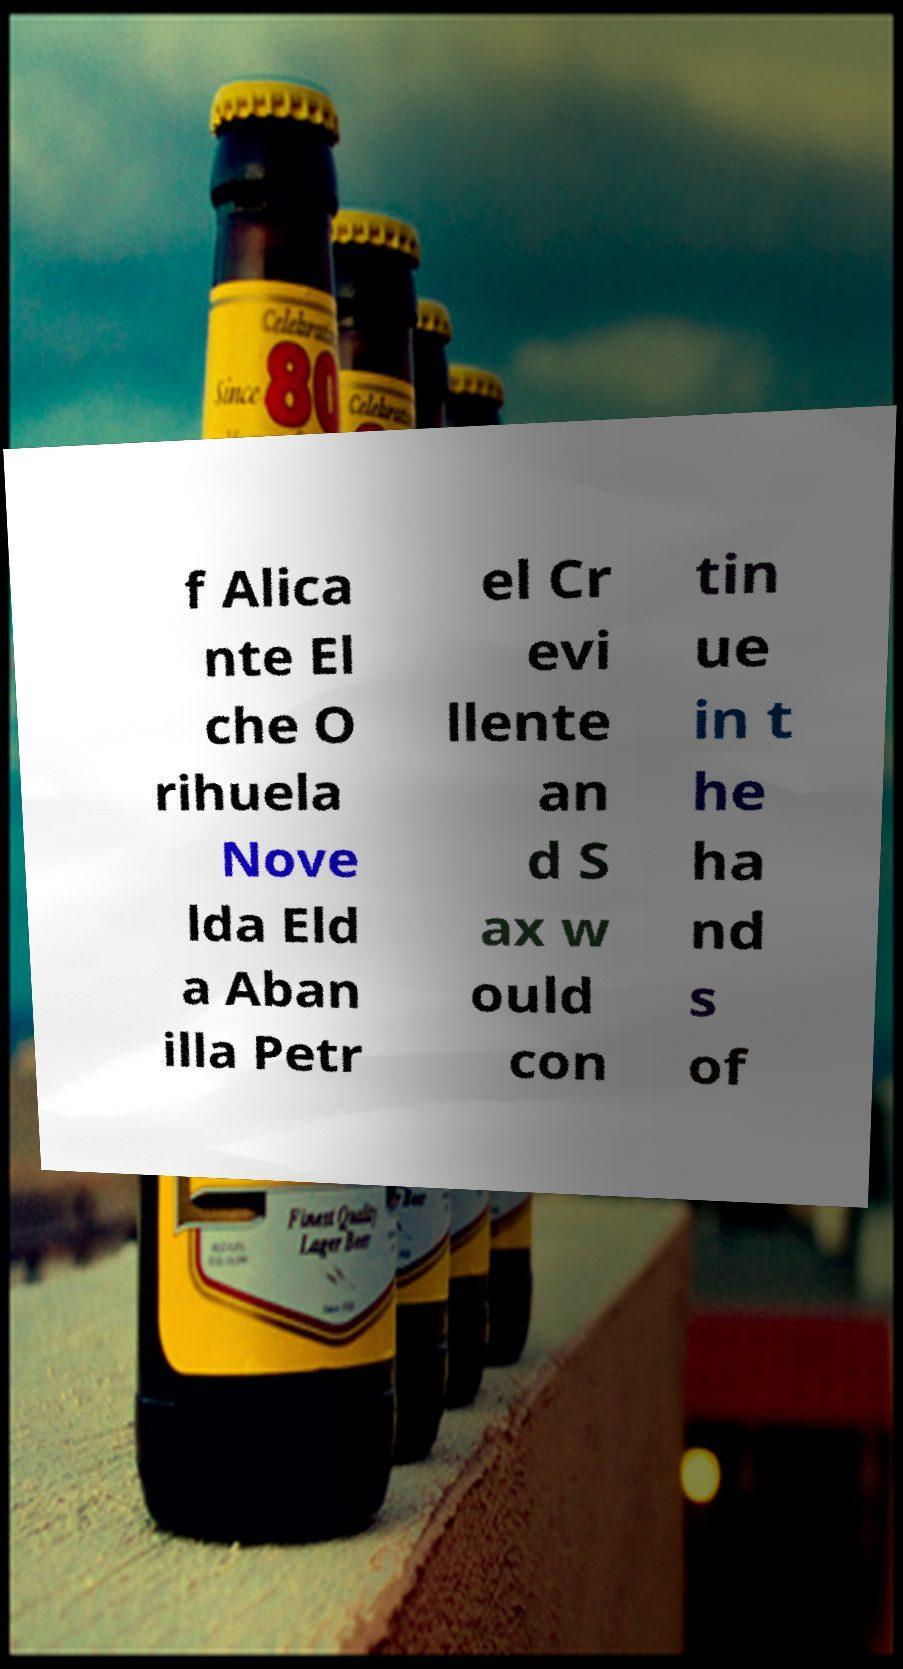There's text embedded in this image that I need extracted. Can you transcribe it verbatim? f Alica nte El che O rihuela Nove lda Eld a Aban illa Petr el Cr evi llente an d S ax w ould con tin ue in t he ha nd s of 